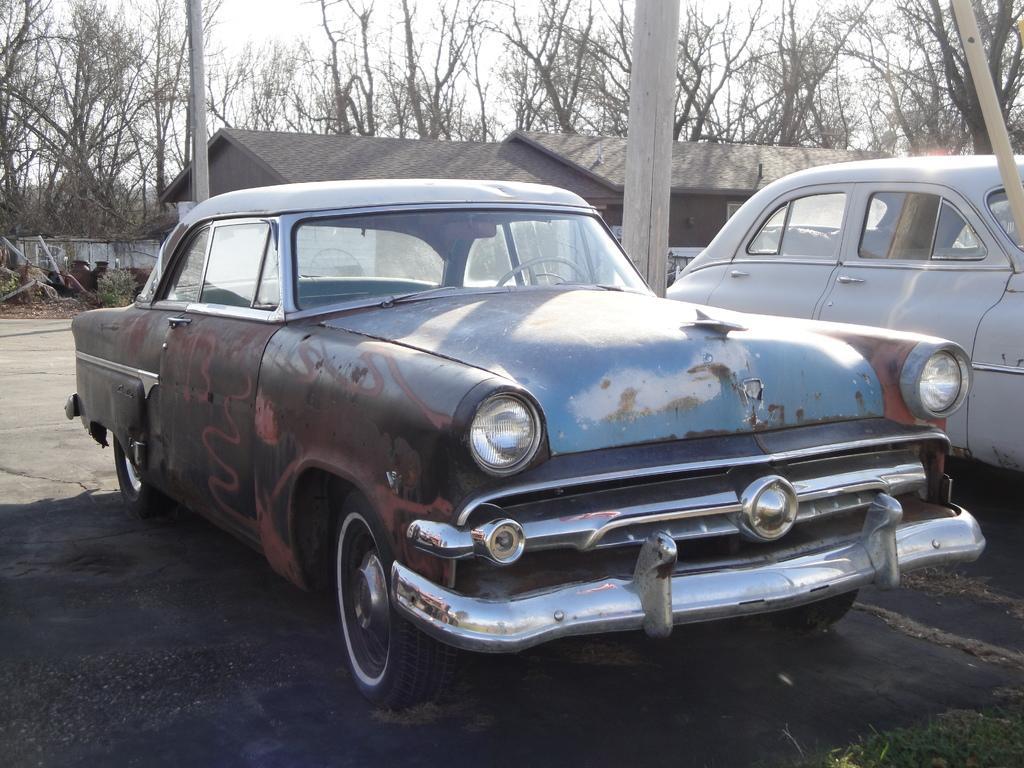In one or two sentences, can you explain what this image depicts? In the foreground of this image, there are two cars on the ground. In the background, we can see people's, houses, trees, wall and the sky. 